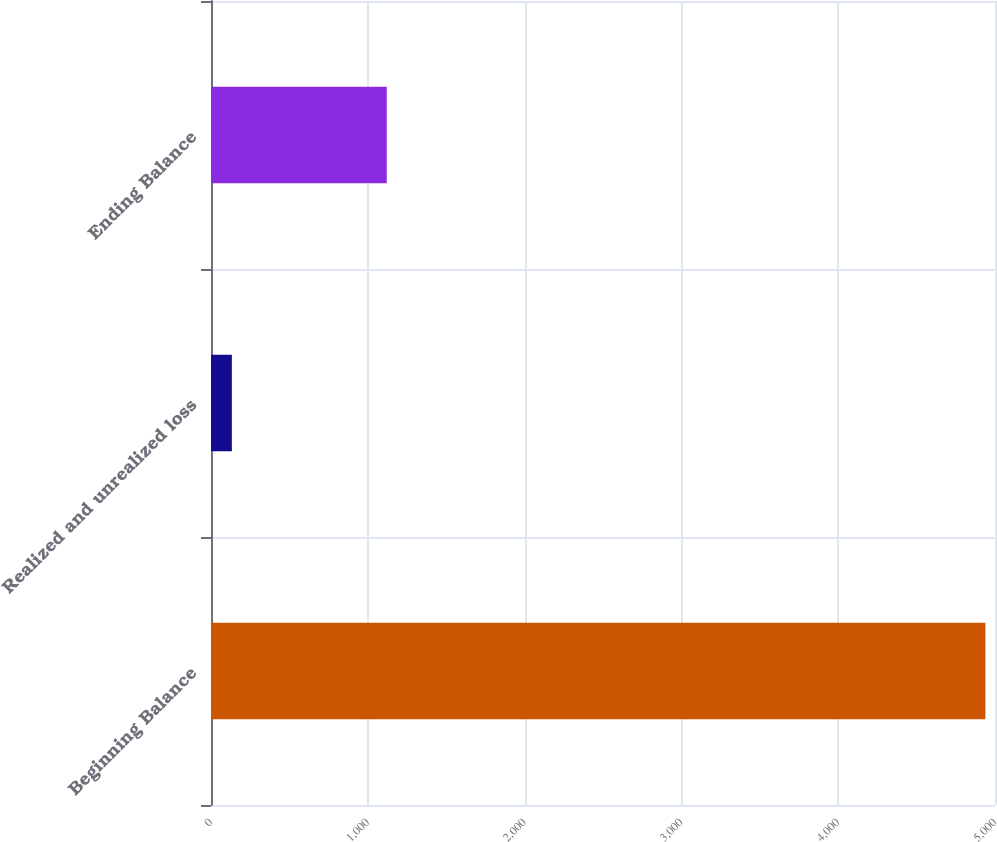<chart> <loc_0><loc_0><loc_500><loc_500><bar_chart><fcel>Beginning Balance<fcel>Realized and unrealized loss<fcel>Ending Balance<nl><fcel>4939<fcel>133<fcel>1121<nl></chart> 